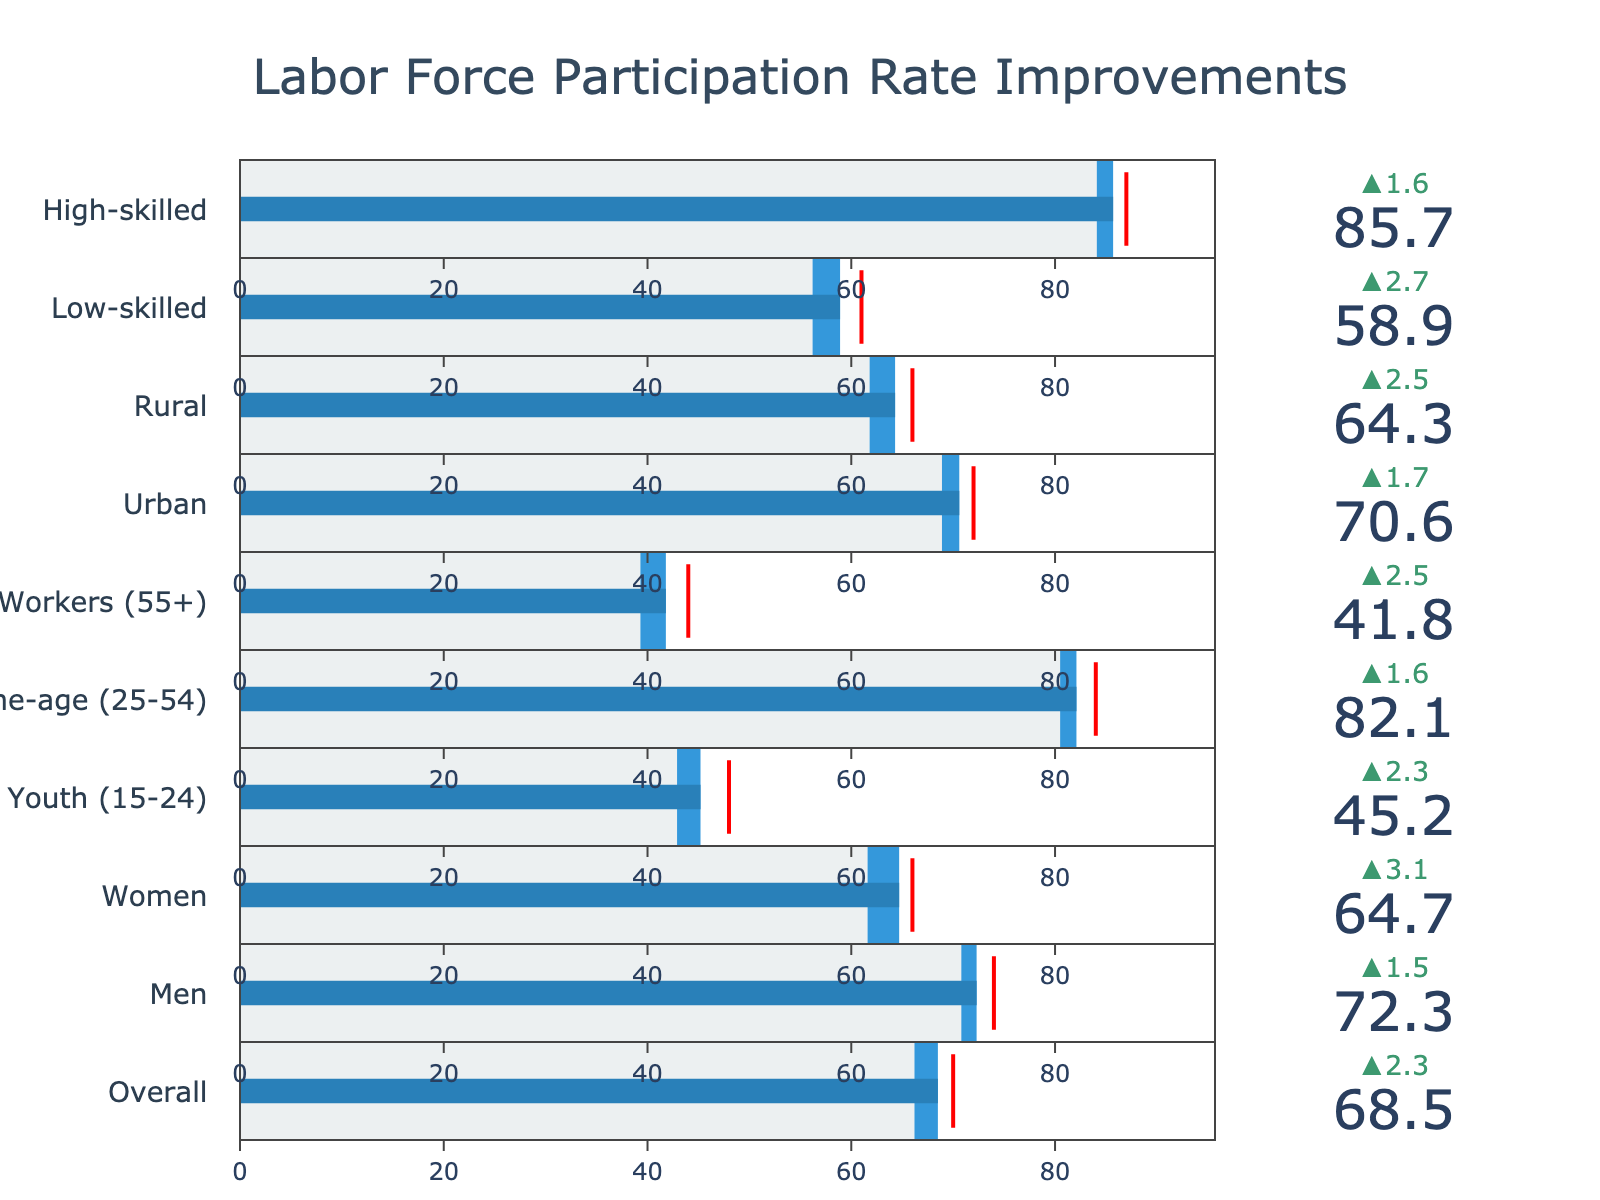what is the target value for Women? The target value for each category is indicated by the red line in each bullet chart. Looking at the bullet chart for Women, the target value is 66.
Answer: 66 Which demographic group has the highest actual labor force participation rate? The actual labor force participation rate for each category is indicated by the blue bar. The category with the highest value is High-skilled, which is 85.7.
Answer: High-skilled What is the difference between the actual and previous year values for Youth (15-24)? Subtract the 'Previous Year' value from the 'Actual' value for Youth (15-24). The difference is 45.2 - 42.9.
Answer: 2.3 How much improvement is needed for Urban demographic to meet the target? Subtract the 'Actual' value from the 'Target' value for Urban. The difference is 72 - 70.6.
Answer: 1.4 Which demographic category fell short the most from their target value? Subtract the 'Actual' value from the 'Target' value for each category, find the maximum. Older Workers (55+): 44 - 41.8 = 2.2, the highest shortfall among all groups.
Answer: Older Workers (55+) Compare the labor force participation rates between Men and Women. Who has a greater rate, and by how much? The 'Actual' value for Men is 72.3, and for Women, it is 64.7. Subtract the value for Women from Men. 72.3 - 64.7
Answer: Men by 7.6 Which demographic group showed the highest improvement from the previous year? Subtract the 'Previous Year' value from the 'Actual' value for each category and find the maximum improvement. Women: 64.7 - 61.6 = 3.1, the highest improvement.
Answer: Women What's the average 'Actual' labor force participation rate for Prime-age (25-54) and Older Workers (55+)? Add the 'Actual' values of Prime-age (25-54) and Older Workers (55+), then divide by 2. (82.1 + 41.8) / 2.
Answer: 61.95 Identify the demographic group with the second-lowest actual labor force participation rate. List the 'Actual' values for all categories and sort them in ascending order. The second-lowest value is for Older Workers (55+) with 41.8, after Youth (15-24) with 45.2.
Answer: Older Workers (55+) What is the range of actual labor force participation rates across the different demographics? Identify the maximum and minimum 'Actual' values and find the difference. The maximum is 85.7 (High-skilled), and the minimum is 41.8 (Older Workers). Range: 85.7 - 41.8.
Answer: 43.9 